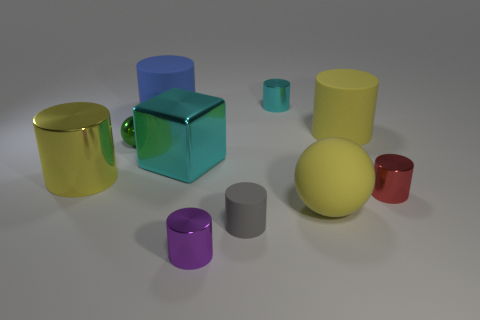The tiny cylinder behind the big cylinder in front of the large yellow matte cylinder is made of what material?
Give a very brief answer. Metal. Are there any yellow cylinders that have the same material as the tiny purple cylinder?
Ensure brevity in your answer.  Yes. Are there any yellow metal things in front of the large matte object that is on the right side of the big matte sphere?
Your answer should be compact. Yes. What is the material of the yellow thing that is in front of the small red shiny cylinder?
Keep it short and to the point. Rubber. Is the small gray matte thing the same shape as the red object?
Offer a terse response. Yes. What is the color of the tiny shiny object that is to the right of the big yellow cylinder that is to the right of the metal cylinder that is in front of the tiny gray rubber cylinder?
Your answer should be very brief. Red. What number of tiny cyan things are the same shape as the large blue object?
Give a very brief answer. 1. What size is the yellow rubber thing that is behind the yellow object on the left side of the big blue rubber cylinder?
Your response must be concise. Large. Is the size of the yellow shiny object the same as the cube?
Keep it short and to the point. Yes. There is a rubber cylinder that is in front of the yellow cylinder that is on the left side of the small gray rubber cylinder; is there a yellow ball to the left of it?
Your response must be concise. No. 